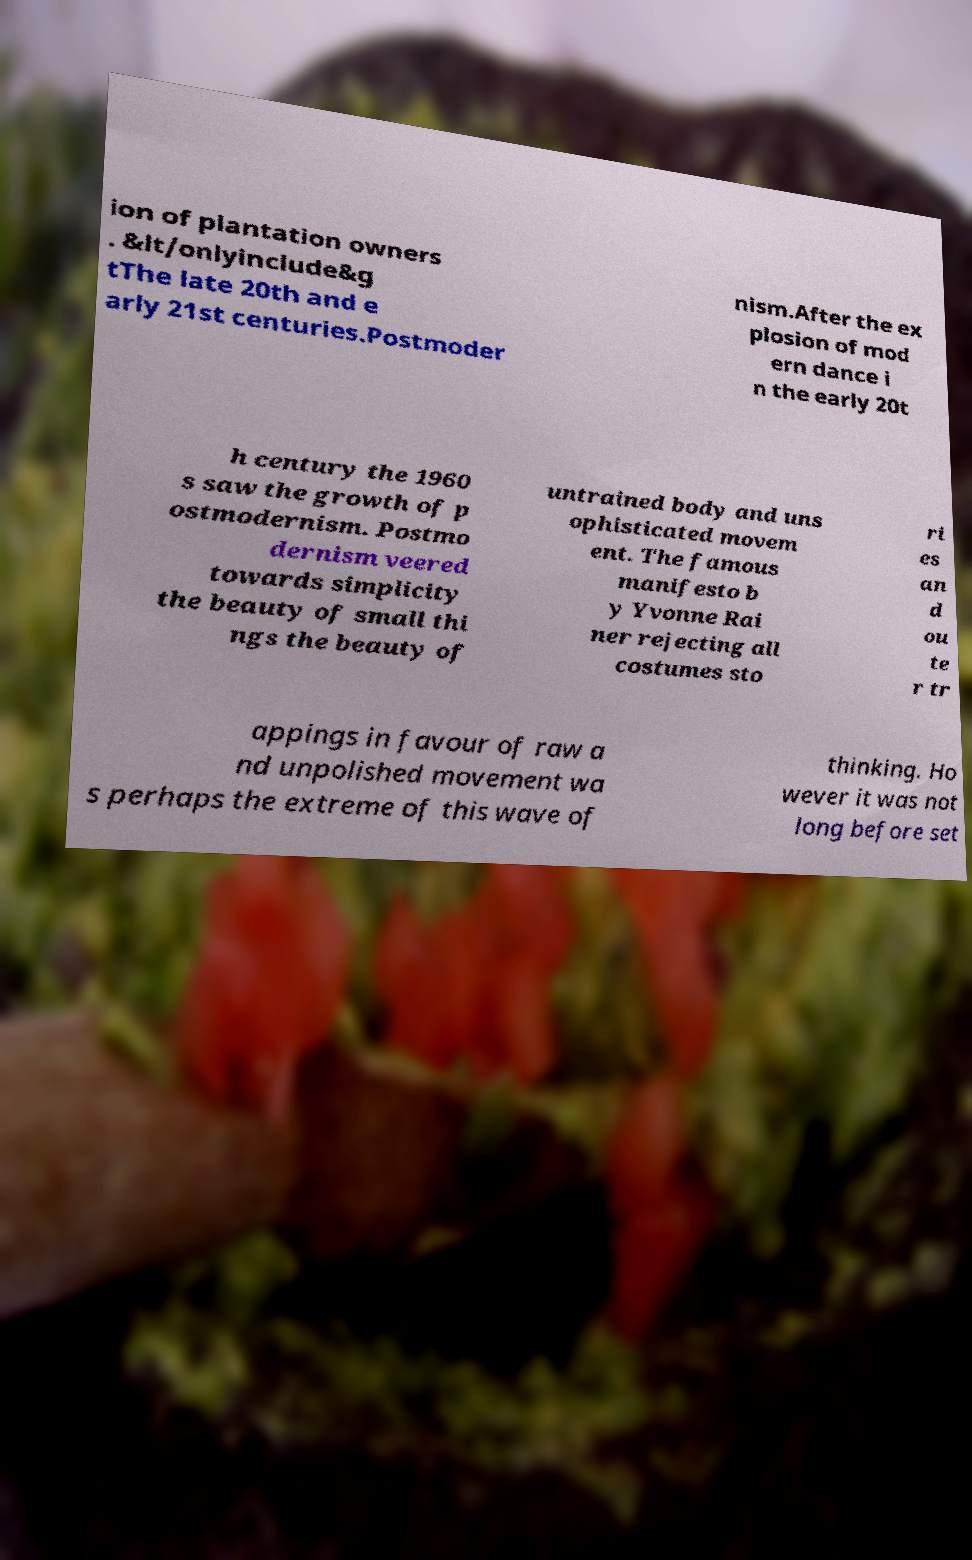There's text embedded in this image that I need extracted. Can you transcribe it verbatim? ion of plantation owners . &lt/onlyinclude&g tThe late 20th and e arly 21st centuries.Postmoder nism.After the ex plosion of mod ern dance i n the early 20t h century the 1960 s saw the growth of p ostmodernism. Postmo dernism veered towards simplicity the beauty of small thi ngs the beauty of untrained body and uns ophisticated movem ent. The famous manifesto b y Yvonne Rai ner rejecting all costumes sto ri es an d ou te r tr appings in favour of raw a nd unpolished movement wa s perhaps the extreme of this wave of thinking. Ho wever it was not long before set 